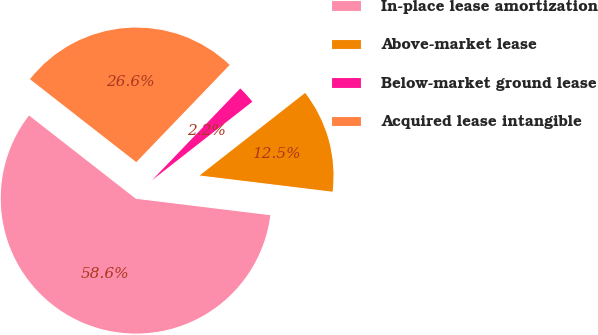<chart> <loc_0><loc_0><loc_500><loc_500><pie_chart><fcel>In-place lease amortization<fcel>Above-market lease<fcel>Below-market ground lease<fcel>Acquired lease intangible<nl><fcel>58.61%<fcel>12.5%<fcel>2.25%<fcel>26.64%<nl></chart> 